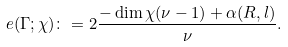<formula> <loc_0><loc_0><loc_500><loc_500>e ( \Gamma ; \chi ) \colon = 2 \frac { - \dim \chi ( \nu - 1 ) + \alpha ( R , l ) } { \nu } .</formula> 